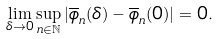<formula> <loc_0><loc_0><loc_500><loc_500>\lim _ { \delta \to 0 } \sup _ { n \in \mathbb { N } } | \overline { \phi } _ { n } ( \delta ) - \overline { \phi } _ { n } ( 0 ) | = 0 .</formula> 